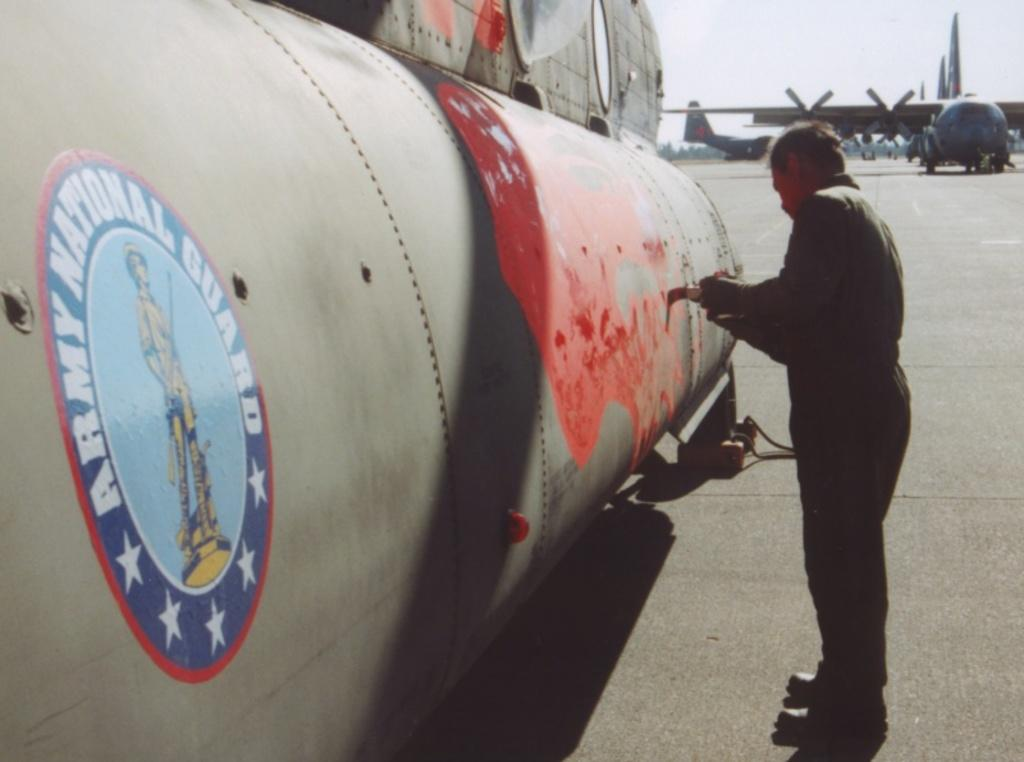Provide a one-sentence caption for the provided image. A painter touches up a plane belonging to the army. 